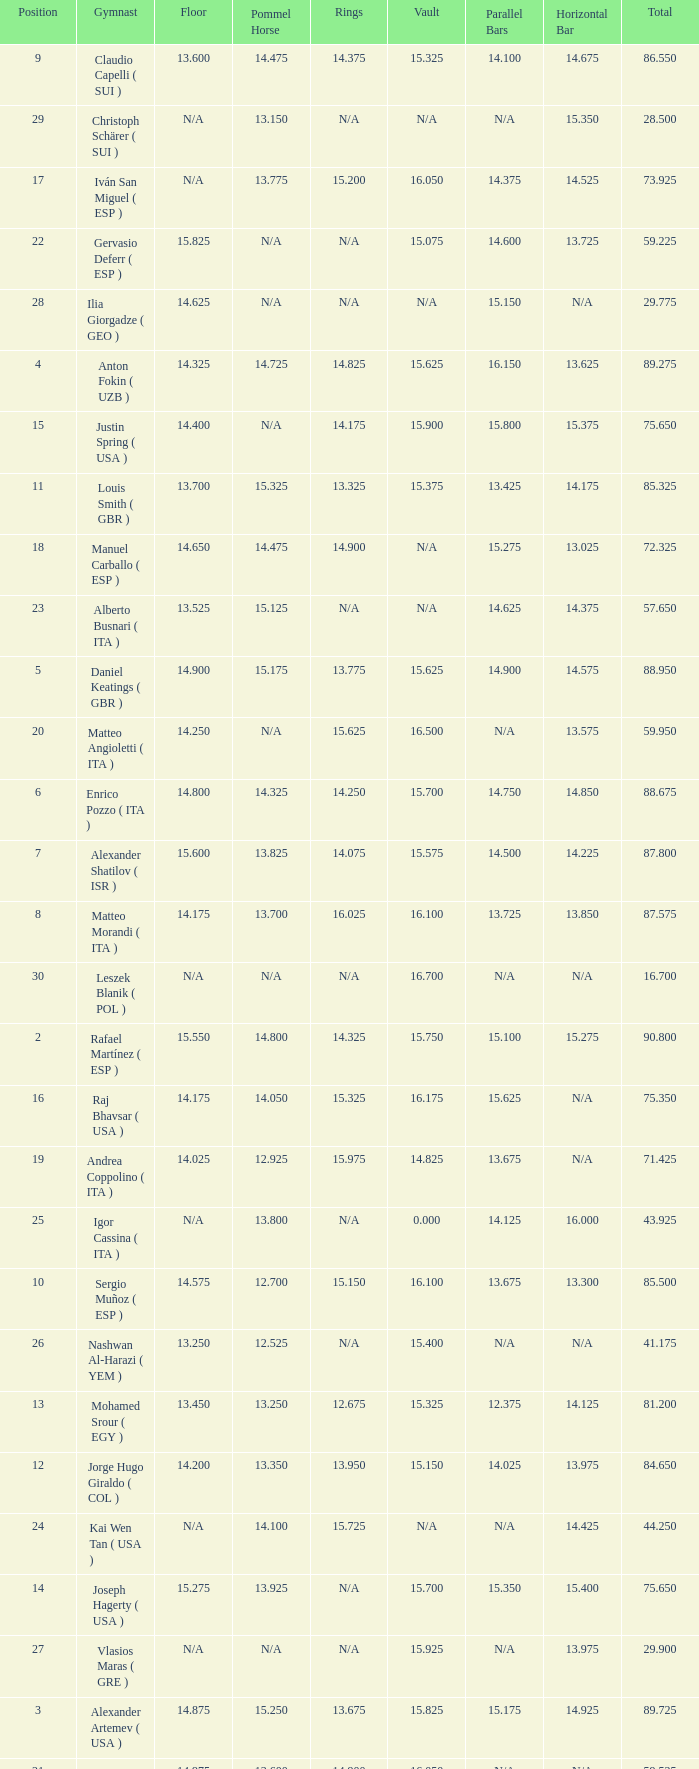If the horizontal bar is n/a and the floor is 14.175, what is the number for the parallel bars? 15.625. 